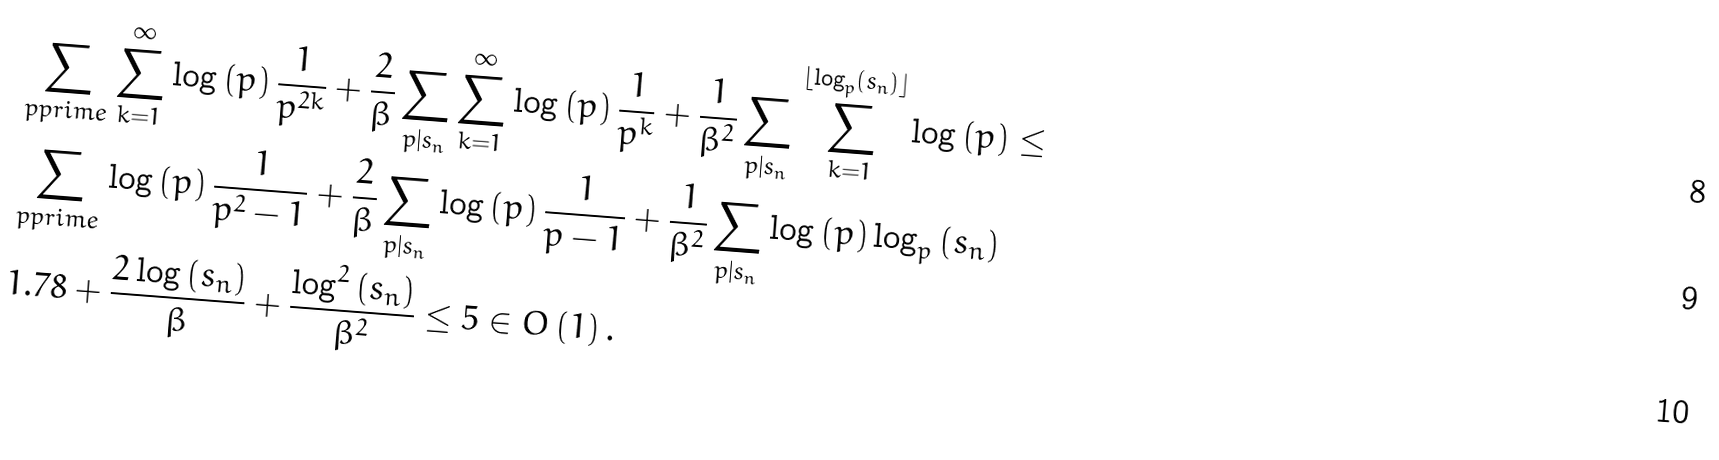<formula> <loc_0><loc_0><loc_500><loc_500>& \sum _ { p p r i m e } \sum _ { k = 1 } ^ { \infty } \log \left ( p \right ) \frac { 1 } { p ^ { 2 k } } + \frac { 2 } { \beta } \sum _ { p | s _ { n } } \sum _ { k = 1 } ^ { \infty } \log \left ( p \right ) \frac { 1 } { p ^ { k } } + \frac { 1 } { \beta ^ { 2 } } \sum _ { p | s _ { n } } \sum _ { k = 1 } ^ { \lfloor \log _ { p } \left ( s _ { n } \right ) \rfloor } \log \left ( p \right ) \leq \\ & \sum _ { p p r i m e } \log \left ( p \right ) \frac { 1 } { p ^ { 2 } - 1 } + \frac { 2 } { \beta } \sum _ { p | s _ { n } } \log \left ( p \right ) \frac { 1 } { p - 1 } + \frac { 1 } { \beta ^ { 2 } } \sum _ { p | s _ { n } } \log \left ( p \right ) \log _ { p } \left ( s _ { n } \right ) \\ & 1 . 7 8 + \frac { 2 \log \left ( s _ { n } \right ) } { \beta } + \frac { \log ^ { 2 } \left ( s _ { n } \right ) } { \beta ^ { 2 } } \leq 5 \in O \left ( 1 \right ) .</formula> 